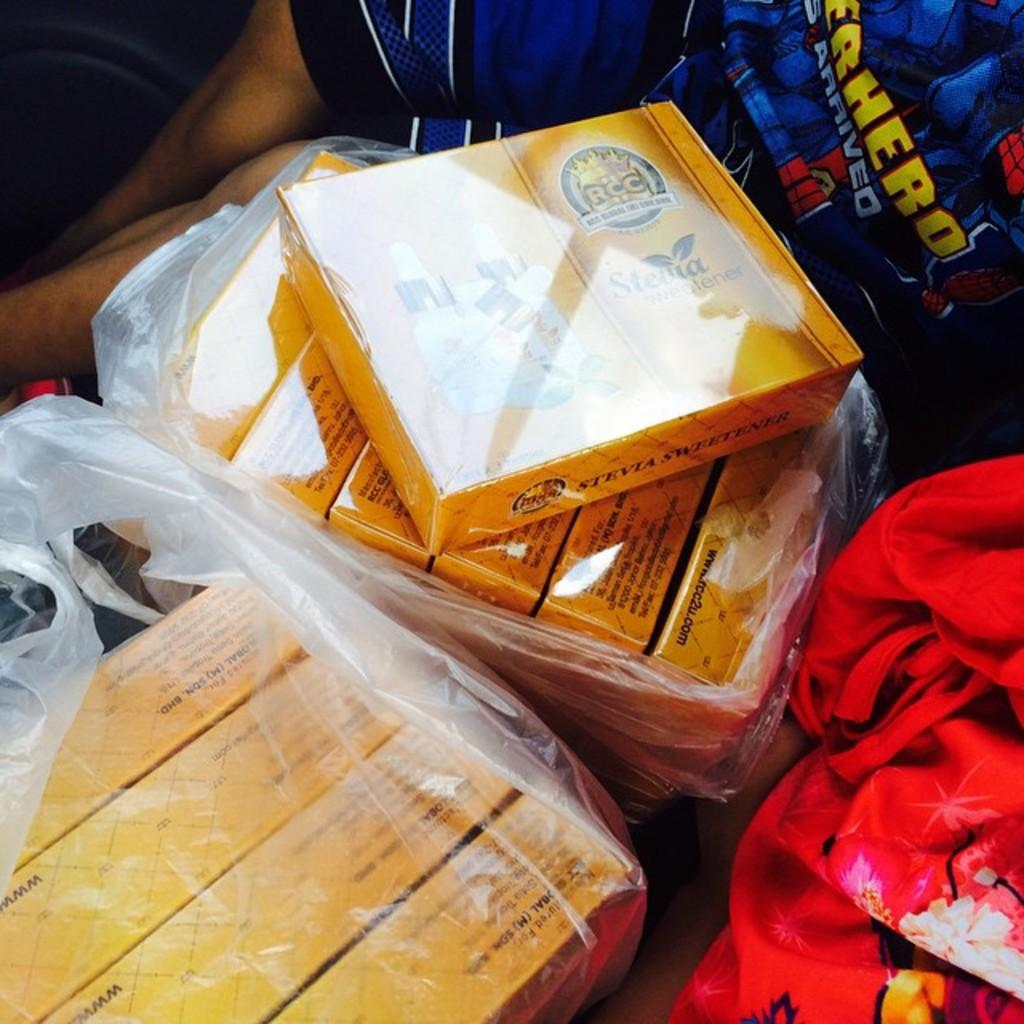What objects are located in the center of the image? There are boxes, plastic covers, and a cloth in the center of the image. Can you describe the cloth in the image? The cloth is in the center of the image. Is there anyone visible in the image? Yes, there is a person sitting in the background of the image. What type of plantation can be seen in the background of the image? There is no plantation visible in the image; it only shows a person sitting in the background. What channel is the person watching on the television in the image? There is no television present in the image, so it is not possible to determine what channel the person might be watching. 